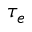<formula> <loc_0><loc_0><loc_500><loc_500>\tau _ { e }</formula> 